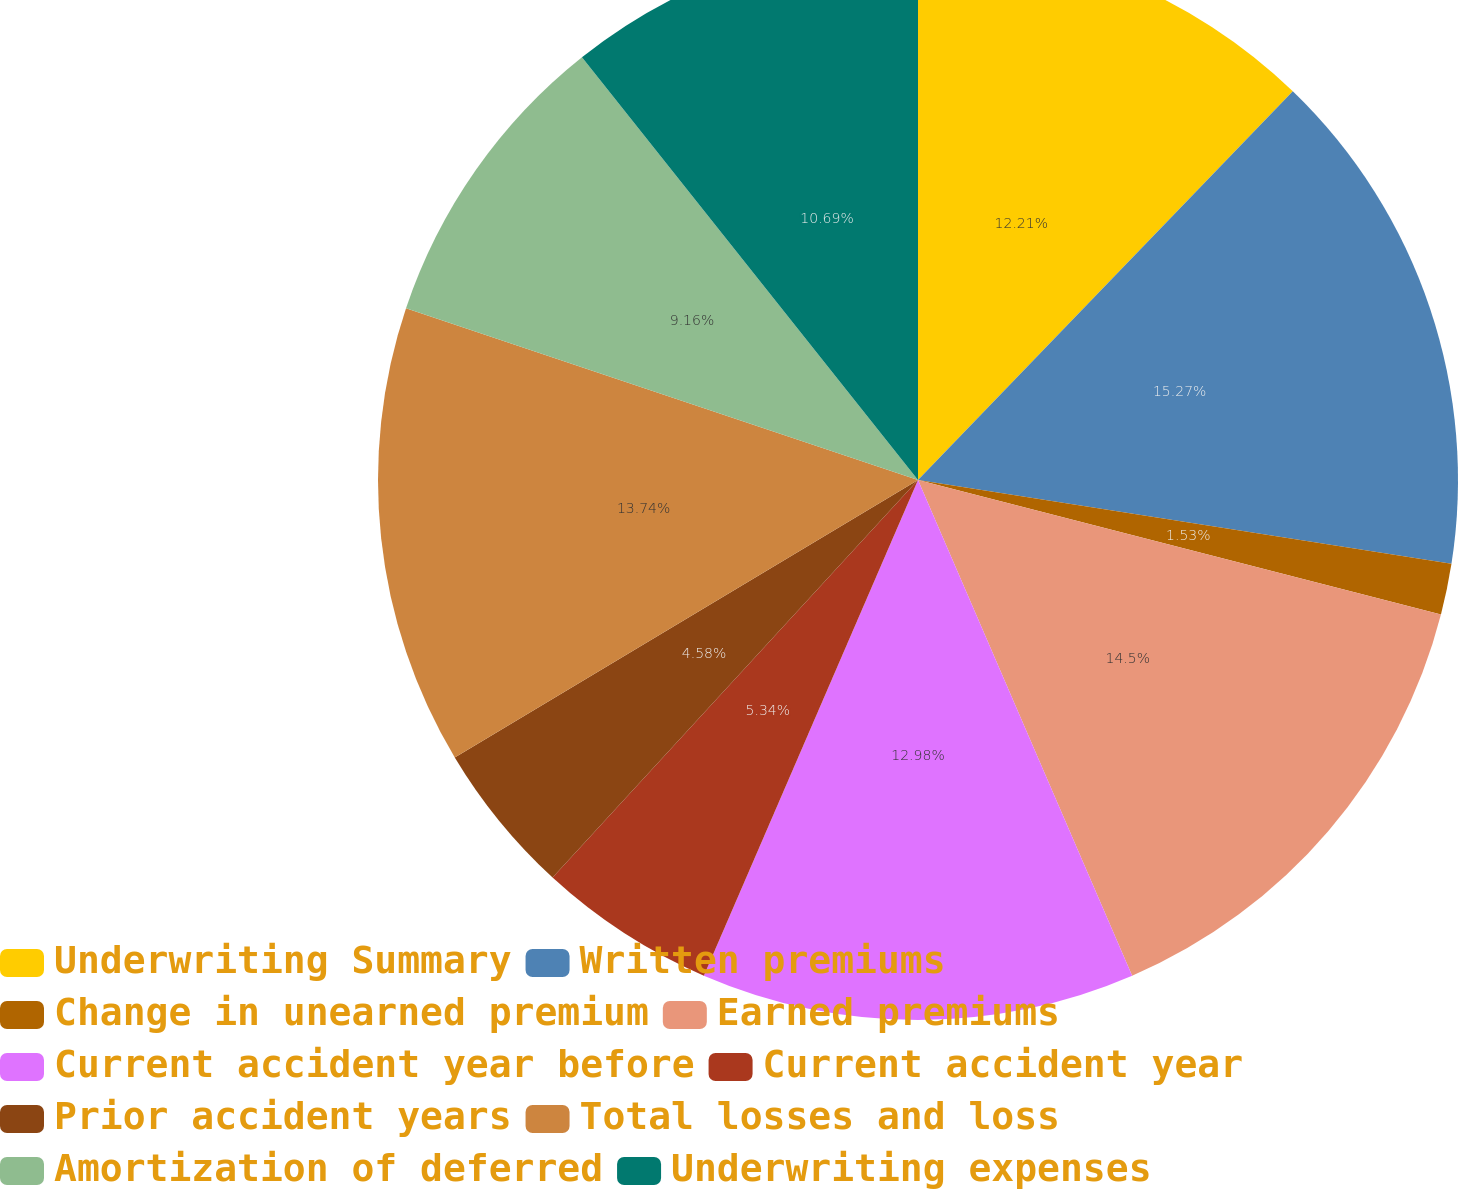Convert chart to OTSL. <chart><loc_0><loc_0><loc_500><loc_500><pie_chart><fcel>Underwriting Summary<fcel>Written premiums<fcel>Change in unearned premium<fcel>Earned premiums<fcel>Current accident year before<fcel>Current accident year<fcel>Prior accident years<fcel>Total losses and loss<fcel>Amortization of deferred<fcel>Underwriting expenses<nl><fcel>12.21%<fcel>15.27%<fcel>1.53%<fcel>14.5%<fcel>12.98%<fcel>5.34%<fcel>4.58%<fcel>13.74%<fcel>9.16%<fcel>10.69%<nl></chart> 